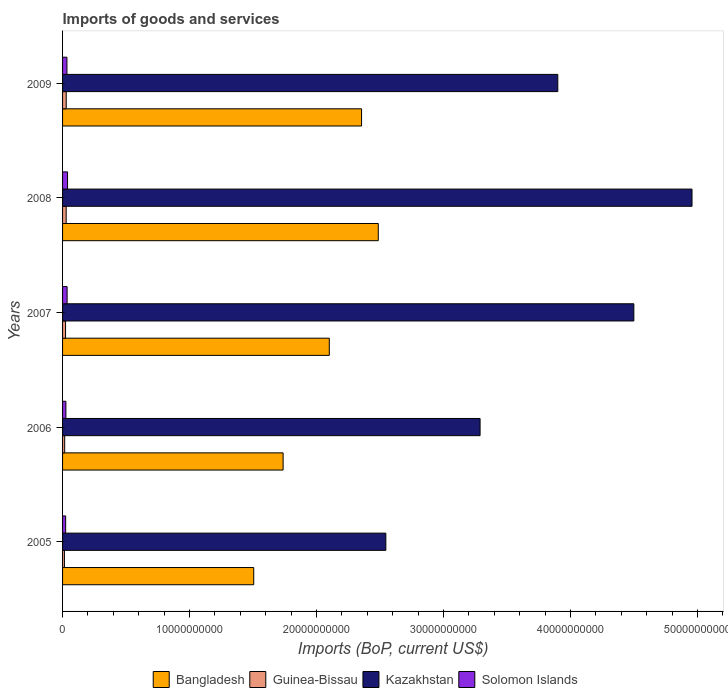How many different coloured bars are there?
Ensure brevity in your answer.  4. Are the number of bars per tick equal to the number of legend labels?
Your answer should be very brief. Yes. How many bars are there on the 3rd tick from the bottom?
Provide a succinct answer. 4. What is the label of the 4th group of bars from the top?
Ensure brevity in your answer.  2006. In how many cases, is the number of bars for a given year not equal to the number of legend labels?
Keep it short and to the point. 0. What is the amount spent on imports in Bangladesh in 2008?
Your response must be concise. 2.49e+1. Across all years, what is the maximum amount spent on imports in Guinea-Bissau?
Provide a short and direct response. 2.89e+08. Across all years, what is the minimum amount spent on imports in Solomon Islands?
Your answer should be compact. 2.43e+08. In which year was the amount spent on imports in Solomon Islands maximum?
Your answer should be compact. 2008. In which year was the amount spent on imports in Bangladesh minimum?
Offer a terse response. 2005. What is the total amount spent on imports in Solomon Islands in the graph?
Give a very brief answer. 1.60e+09. What is the difference between the amount spent on imports in Bangladesh in 2005 and that in 2006?
Provide a succinct answer. -2.31e+09. What is the difference between the amount spent on imports in Bangladesh in 2008 and the amount spent on imports in Guinea-Bissau in 2007?
Provide a short and direct response. 2.46e+1. What is the average amount spent on imports in Kazakhstan per year?
Keep it short and to the point. 3.84e+1. In the year 2007, what is the difference between the amount spent on imports in Solomon Islands and amount spent on imports in Bangladesh?
Keep it short and to the point. -2.06e+1. What is the ratio of the amount spent on imports in Kazakhstan in 2005 to that in 2008?
Give a very brief answer. 0.51. Is the amount spent on imports in Guinea-Bissau in 2006 less than that in 2007?
Keep it short and to the point. Yes. Is the difference between the amount spent on imports in Solomon Islands in 2006 and 2009 greater than the difference between the amount spent on imports in Bangladesh in 2006 and 2009?
Offer a terse response. Yes. What is the difference between the highest and the second highest amount spent on imports in Solomon Islands?
Your answer should be very brief. 3.50e+07. What is the difference between the highest and the lowest amount spent on imports in Bangladesh?
Your response must be concise. 9.81e+09. In how many years, is the amount spent on imports in Solomon Islands greater than the average amount spent on imports in Solomon Islands taken over all years?
Keep it short and to the point. 3. Is the sum of the amount spent on imports in Guinea-Bissau in 2006 and 2009 greater than the maximum amount spent on imports in Kazakhstan across all years?
Your response must be concise. No. What does the 4th bar from the top in 2009 represents?
Keep it short and to the point. Bangladesh. What does the 2nd bar from the bottom in 2007 represents?
Offer a very short reply. Guinea-Bissau. Are all the bars in the graph horizontal?
Offer a terse response. Yes. What is the difference between two consecutive major ticks on the X-axis?
Provide a succinct answer. 1.00e+1. Does the graph contain any zero values?
Provide a succinct answer. No. How are the legend labels stacked?
Ensure brevity in your answer.  Horizontal. What is the title of the graph?
Ensure brevity in your answer.  Imports of goods and services. Does "East Asia (developing only)" appear as one of the legend labels in the graph?
Your response must be concise. No. What is the label or title of the X-axis?
Your response must be concise. Imports (BoP, current US$). What is the Imports (BoP, current US$) in Bangladesh in 2005?
Ensure brevity in your answer.  1.51e+1. What is the Imports (BoP, current US$) in Guinea-Bissau in 2005?
Offer a very short reply. 1.48e+08. What is the Imports (BoP, current US$) in Kazakhstan in 2005?
Ensure brevity in your answer.  2.55e+1. What is the Imports (BoP, current US$) in Solomon Islands in 2005?
Your answer should be very brief. 2.43e+08. What is the Imports (BoP, current US$) of Bangladesh in 2006?
Your answer should be compact. 1.74e+1. What is the Imports (BoP, current US$) of Guinea-Bissau in 2006?
Give a very brief answer. 1.67e+08. What is the Imports (BoP, current US$) of Kazakhstan in 2006?
Give a very brief answer. 3.29e+1. What is the Imports (BoP, current US$) of Solomon Islands in 2006?
Offer a very short reply. 2.63e+08. What is the Imports (BoP, current US$) of Bangladesh in 2007?
Your answer should be compact. 2.10e+1. What is the Imports (BoP, current US$) in Guinea-Bissau in 2007?
Offer a very short reply. 2.36e+08. What is the Imports (BoP, current US$) of Kazakhstan in 2007?
Provide a succinct answer. 4.50e+1. What is the Imports (BoP, current US$) in Solomon Islands in 2007?
Keep it short and to the point. 3.58e+08. What is the Imports (BoP, current US$) of Bangladesh in 2008?
Offer a terse response. 2.49e+1. What is the Imports (BoP, current US$) in Guinea-Bissau in 2008?
Keep it short and to the point. 2.84e+08. What is the Imports (BoP, current US$) of Kazakhstan in 2008?
Provide a succinct answer. 4.96e+1. What is the Imports (BoP, current US$) of Solomon Islands in 2008?
Your answer should be very brief. 3.93e+08. What is the Imports (BoP, current US$) of Bangladesh in 2009?
Offer a very short reply. 2.35e+1. What is the Imports (BoP, current US$) in Guinea-Bissau in 2009?
Keep it short and to the point. 2.89e+08. What is the Imports (BoP, current US$) of Kazakhstan in 2009?
Your answer should be compact. 3.90e+1. What is the Imports (BoP, current US$) of Solomon Islands in 2009?
Ensure brevity in your answer.  3.44e+08. Across all years, what is the maximum Imports (BoP, current US$) in Bangladesh?
Offer a terse response. 2.49e+1. Across all years, what is the maximum Imports (BoP, current US$) in Guinea-Bissau?
Your answer should be compact. 2.89e+08. Across all years, what is the maximum Imports (BoP, current US$) in Kazakhstan?
Make the answer very short. 4.96e+1. Across all years, what is the maximum Imports (BoP, current US$) in Solomon Islands?
Make the answer very short. 3.93e+08. Across all years, what is the minimum Imports (BoP, current US$) in Bangladesh?
Your answer should be very brief. 1.51e+1. Across all years, what is the minimum Imports (BoP, current US$) of Guinea-Bissau?
Ensure brevity in your answer.  1.48e+08. Across all years, what is the minimum Imports (BoP, current US$) of Kazakhstan?
Provide a short and direct response. 2.55e+1. Across all years, what is the minimum Imports (BoP, current US$) of Solomon Islands?
Offer a very short reply. 2.43e+08. What is the total Imports (BoP, current US$) of Bangladesh in the graph?
Your answer should be compact. 1.02e+11. What is the total Imports (BoP, current US$) of Guinea-Bissau in the graph?
Ensure brevity in your answer.  1.12e+09. What is the total Imports (BoP, current US$) in Kazakhstan in the graph?
Keep it short and to the point. 1.92e+11. What is the total Imports (BoP, current US$) in Solomon Islands in the graph?
Provide a short and direct response. 1.60e+09. What is the difference between the Imports (BoP, current US$) of Bangladesh in 2005 and that in 2006?
Offer a terse response. -2.31e+09. What is the difference between the Imports (BoP, current US$) of Guinea-Bissau in 2005 and that in 2006?
Offer a very short reply. -1.90e+07. What is the difference between the Imports (BoP, current US$) in Kazakhstan in 2005 and that in 2006?
Your answer should be compact. -7.42e+09. What is the difference between the Imports (BoP, current US$) in Solomon Islands in 2005 and that in 2006?
Give a very brief answer. -2.03e+07. What is the difference between the Imports (BoP, current US$) of Bangladesh in 2005 and that in 2007?
Offer a terse response. -5.95e+09. What is the difference between the Imports (BoP, current US$) of Guinea-Bissau in 2005 and that in 2007?
Your answer should be compact. -8.85e+07. What is the difference between the Imports (BoP, current US$) of Kazakhstan in 2005 and that in 2007?
Offer a terse response. -1.95e+1. What is the difference between the Imports (BoP, current US$) in Solomon Islands in 2005 and that in 2007?
Your answer should be very brief. -1.15e+08. What is the difference between the Imports (BoP, current US$) in Bangladesh in 2005 and that in 2008?
Make the answer very short. -9.81e+09. What is the difference between the Imports (BoP, current US$) of Guinea-Bissau in 2005 and that in 2008?
Your answer should be very brief. -1.36e+08. What is the difference between the Imports (BoP, current US$) of Kazakhstan in 2005 and that in 2008?
Provide a short and direct response. -2.41e+1. What is the difference between the Imports (BoP, current US$) of Solomon Islands in 2005 and that in 2008?
Offer a terse response. -1.50e+08. What is the difference between the Imports (BoP, current US$) of Bangladesh in 2005 and that in 2009?
Ensure brevity in your answer.  -8.49e+09. What is the difference between the Imports (BoP, current US$) in Guinea-Bissau in 2005 and that in 2009?
Your answer should be very brief. -1.42e+08. What is the difference between the Imports (BoP, current US$) of Kazakhstan in 2005 and that in 2009?
Make the answer very short. -1.35e+1. What is the difference between the Imports (BoP, current US$) in Solomon Islands in 2005 and that in 2009?
Provide a short and direct response. -1.01e+08. What is the difference between the Imports (BoP, current US$) in Bangladesh in 2006 and that in 2007?
Keep it short and to the point. -3.64e+09. What is the difference between the Imports (BoP, current US$) of Guinea-Bissau in 2006 and that in 2007?
Give a very brief answer. -6.95e+07. What is the difference between the Imports (BoP, current US$) of Kazakhstan in 2006 and that in 2007?
Keep it short and to the point. -1.21e+1. What is the difference between the Imports (BoP, current US$) of Solomon Islands in 2006 and that in 2007?
Provide a succinct answer. -9.44e+07. What is the difference between the Imports (BoP, current US$) of Bangladesh in 2006 and that in 2008?
Make the answer very short. -7.50e+09. What is the difference between the Imports (BoP, current US$) of Guinea-Bissau in 2006 and that in 2008?
Provide a short and direct response. -1.17e+08. What is the difference between the Imports (BoP, current US$) in Kazakhstan in 2006 and that in 2008?
Ensure brevity in your answer.  -1.67e+1. What is the difference between the Imports (BoP, current US$) of Solomon Islands in 2006 and that in 2008?
Ensure brevity in your answer.  -1.29e+08. What is the difference between the Imports (BoP, current US$) in Bangladesh in 2006 and that in 2009?
Provide a succinct answer. -6.18e+09. What is the difference between the Imports (BoP, current US$) in Guinea-Bissau in 2006 and that in 2009?
Make the answer very short. -1.23e+08. What is the difference between the Imports (BoP, current US$) of Kazakhstan in 2006 and that in 2009?
Your response must be concise. -6.12e+09. What is the difference between the Imports (BoP, current US$) in Solomon Islands in 2006 and that in 2009?
Your answer should be very brief. -8.06e+07. What is the difference between the Imports (BoP, current US$) of Bangladesh in 2007 and that in 2008?
Your answer should be very brief. -3.86e+09. What is the difference between the Imports (BoP, current US$) in Guinea-Bissau in 2007 and that in 2008?
Your response must be concise. -4.78e+07. What is the difference between the Imports (BoP, current US$) of Kazakhstan in 2007 and that in 2008?
Your response must be concise. -4.58e+09. What is the difference between the Imports (BoP, current US$) in Solomon Islands in 2007 and that in 2008?
Keep it short and to the point. -3.50e+07. What is the difference between the Imports (BoP, current US$) of Bangladesh in 2007 and that in 2009?
Your answer should be very brief. -2.54e+09. What is the difference between the Imports (BoP, current US$) in Guinea-Bissau in 2007 and that in 2009?
Your answer should be compact. -5.31e+07. What is the difference between the Imports (BoP, current US$) in Kazakhstan in 2007 and that in 2009?
Provide a succinct answer. 5.99e+09. What is the difference between the Imports (BoP, current US$) in Solomon Islands in 2007 and that in 2009?
Provide a succinct answer. 1.37e+07. What is the difference between the Imports (BoP, current US$) in Bangladesh in 2008 and that in 2009?
Provide a short and direct response. 1.32e+09. What is the difference between the Imports (BoP, current US$) in Guinea-Bissau in 2008 and that in 2009?
Give a very brief answer. -5.23e+06. What is the difference between the Imports (BoP, current US$) of Kazakhstan in 2008 and that in 2009?
Your answer should be compact. 1.06e+1. What is the difference between the Imports (BoP, current US$) of Solomon Islands in 2008 and that in 2009?
Your answer should be very brief. 4.87e+07. What is the difference between the Imports (BoP, current US$) of Bangladesh in 2005 and the Imports (BoP, current US$) of Guinea-Bissau in 2006?
Offer a terse response. 1.49e+1. What is the difference between the Imports (BoP, current US$) in Bangladesh in 2005 and the Imports (BoP, current US$) in Kazakhstan in 2006?
Your response must be concise. -1.78e+1. What is the difference between the Imports (BoP, current US$) in Bangladesh in 2005 and the Imports (BoP, current US$) in Solomon Islands in 2006?
Your response must be concise. 1.48e+1. What is the difference between the Imports (BoP, current US$) of Guinea-Bissau in 2005 and the Imports (BoP, current US$) of Kazakhstan in 2006?
Offer a terse response. -3.27e+1. What is the difference between the Imports (BoP, current US$) of Guinea-Bissau in 2005 and the Imports (BoP, current US$) of Solomon Islands in 2006?
Give a very brief answer. -1.16e+08. What is the difference between the Imports (BoP, current US$) in Kazakhstan in 2005 and the Imports (BoP, current US$) in Solomon Islands in 2006?
Make the answer very short. 2.52e+1. What is the difference between the Imports (BoP, current US$) in Bangladesh in 2005 and the Imports (BoP, current US$) in Guinea-Bissau in 2007?
Keep it short and to the point. 1.48e+1. What is the difference between the Imports (BoP, current US$) in Bangladesh in 2005 and the Imports (BoP, current US$) in Kazakhstan in 2007?
Provide a short and direct response. -2.99e+1. What is the difference between the Imports (BoP, current US$) of Bangladesh in 2005 and the Imports (BoP, current US$) of Solomon Islands in 2007?
Give a very brief answer. 1.47e+1. What is the difference between the Imports (BoP, current US$) of Guinea-Bissau in 2005 and the Imports (BoP, current US$) of Kazakhstan in 2007?
Give a very brief answer. -4.48e+1. What is the difference between the Imports (BoP, current US$) in Guinea-Bissau in 2005 and the Imports (BoP, current US$) in Solomon Islands in 2007?
Provide a short and direct response. -2.10e+08. What is the difference between the Imports (BoP, current US$) in Kazakhstan in 2005 and the Imports (BoP, current US$) in Solomon Islands in 2007?
Your response must be concise. 2.51e+1. What is the difference between the Imports (BoP, current US$) of Bangladesh in 2005 and the Imports (BoP, current US$) of Guinea-Bissau in 2008?
Provide a succinct answer. 1.48e+1. What is the difference between the Imports (BoP, current US$) of Bangladesh in 2005 and the Imports (BoP, current US$) of Kazakhstan in 2008?
Provide a succinct answer. -3.45e+1. What is the difference between the Imports (BoP, current US$) of Bangladesh in 2005 and the Imports (BoP, current US$) of Solomon Islands in 2008?
Keep it short and to the point. 1.47e+1. What is the difference between the Imports (BoP, current US$) of Guinea-Bissau in 2005 and the Imports (BoP, current US$) of Kazakhstan in 2008?
Your answer should be compact. -4.94e+1. What is the difference between the Imports (BoP, current US$) of Guinea-Bissau in 2005 and the Imports (BoP, current US$) of Solomon Islands in 2008?
Your response must be concise. -2.45e+08. What is the difference between the Imports (BoP, current US$) in Kazakhstan in 2005 and the Imports (BoP, current US$) in Solomon Islands in 2008?
Give a very brief answer. 2.51e+1. What is the difference between the Imports (BoP, current US$) of Bangladesh in 2005 and the Imports (BoP, current US$) of Guinea-Bissau in 2009?
Make the answer very short. 1.48e+1. What is the difference between the Imports (BoP, current US$) of Bangladesh in 2005 and the Imports (BoP, current US$) of Kazakhstan in 2009?
Keep it short and to the point. -2.39e+1. What is the difference between the Imports (BoP, current US$) of Bangladesh in 2005 and the Imports (BoP, current US$) of Solomon Islands in 2009?
Provide a succinct answer. 1.47e+1. What is the difference between the Imports (BoP, current US$) in Guinea-Bissau in 2005 and the Imports (BoP, current US$) in Kazakhstan in 2009?
Make the answer very short. -3.89e+1. What is the difference between the Imports (BoP, current US$) in Guinea-Bissau in 2005 and the Imports (BoP, current US$) in Solomon Islands in 2009?
Your answer should be very brief. -1.96e+08. What is the difference between the Imports (BoP, current US$) of Kazakhstan in 2005 and the Imports (BoP, current US$) of Solomon Islands in 2009?
Provide a succinct answer. 2.51e+1. What is the difference between the Imports (BoP, current US$) of Bangladesh in 2006 and the Imports (BoP, current US$) of Guinea-Bissau in 2007?
Provide a succinct answer. 1.71e+1. What is the difference between the Imports (BoP, current US$) of Bangladesh in 2006 and the Imports (BoP, current US$) of Kazakhstan in 2007?
Provide a short and direct response. -2.76e+1. What is the difference between the Imports (BoP, current US$) in Bangladesh in 2006 and the Imports (BoP, current US$) in Solomon Islands in 2007?
Ensure brevity in your answer.  1.70e+1. What is the difference between the Imports (BoP, current US$) in Guinea-Bissau in 2006 and the Imports (BoP, current US$) in Kazakhstan in 2007?
Keep it short and to the point. -4.48e+1. What is the difference between the Imports (BoP, current US$) of Guinea-Bissau in 2006 and the Imports (BoP, current US$) of Solomon Islands in 2007?
Ensure brevity in your answer.  -1.91e+08. What is the difference between the Imports (BoP, current US$) of Kazakhstan in 2006 and the Imports (BoP, current US$) of Solomon Islands in 2007?
Make the answer very short. 3.25e+1. What is the difference between the Imports (BoP, current US$) of Bangladesh in 2006 and the Imports (BoP, current US$) of Guinea-Bissau in 2008?
Keep it short and to the point. 1.71e+1. What is the difference between the Imports (BoP, current US$) of Bangladesh in 2006 and the Imports (BoP, current US$) of Kazakhstan in 2008?
Give a very brief answer. -3.22e+1. What is the difference between the Imports (BoP, current US$) in Bangladesh in 2006 and the Imports (BoP, current US$) in Solomon Islands in 2008?
Your response must be concise. 1.70e+1. What is the difference between the Imports (BoP, current US$) in Guinea-Bissau in 2006 and the Imports (BoP, current US$) in Kazakhstan in 2008?
Keep it short and to the point. -4.94e+1. What is the difference between the Imports (BoP, current US$) of Guinea-Bissau in 2006 and the Imports (BoP, current US$) of Solomon Islands in 2008?
Provide a succinct answer. -2.26e+08. What is the difference between the Imports (BoP, current US$) of Kazakhstan in 2006 and the Imports (BoP, current US$) of Solomon Islands in 2008?
Your answer should be very brief. 3.25e+1. What is the difference between the Imports (BoP, current US$) of Bangladesh in 2006 and the Imports (BoP, current US$) of Guinea-Bissau in 2009?
Give a very brief answer. 1.71e+1. What is the difference between the Imports (BoP, current US$) in Bangladesh in 2006 and the Imports (BoP, current US$) in Kazakhstan in 2009?
Your answer should be compact. -2.16e+1. What is the difference between the Imports (BoP, current US$) of Bangladesh in 2006 and the Imports (BoP, current US$) of Solomon Islands in 2009?
Offer a terse response. 1.70e+1. What is the difference between the Imports (BoP, current US$) of Guinea-Bissau in 2006 and the Imports (BoP, current US$) of Kazakhstan in 2009?
Give a very brief answer. -3.88e+1. What is the difference between the Imports (BoP, current US$) in Guinea-Bissau in 2006 and the Imports (BoP, current US$) in Solomon Islands in 2009?
Provide a short and direct response. -1.77e+08. What is the difference between the Imports (BoP, current US$) of Kazakhstan in 2006 and the Imports (BoP, current US$) of Solomon Islands in 2009?
Offer a very short reply. 3.25e+1. What is the difference between the Imports (BoP, current US$) of Bangladesh in 2007 and the Imports (BoP, current US$) of Guinea-Bissau in 2008?
Provide a short and direct response. 2.07e+1. What is the difference between the Imports (BoP, current US$) in Bangladesh in 2007 and the Imports (BoP, current US$) in Kazakhstan in 2008?
Ensure brevity in your answer.  -2.86e+1. What is the difference between the Imports (BoP, current US$) of Bangladesh in 2007 and the Imports (BoP, current US$) of Solomon Islands in 2008?
Make the answer very short. 2.06e+1. What is the difference between the Imports (BoP, current US$) in Guinea-Bissau in 2007 and the Imports (BoP, current US$) in Kazakhstan in 2008?
Your answer should be compact. -4.93e+1. What is the difference between the Imports (BoP, current US$) in Guinea-Bissau in 2007 and the Imports (BoP, current US$) in Solomon Islands in 2008?
Give a very brief answer. -1.57e+08. What is the difference between the Imports (BoP, current US$) of Kazakhstan in 2007 and the Imports (BoP, current US$) of Solomon Islands in 2008?
Keep it short and to the point. 4.46e+1. What is the difference between the Imports (BoP, current US$) of Bangladesh in 2007 and the Imports (BoP, current US$) of Guinea-Bissau in 2009?
Provide a short and direct response. 2.07e+1. What is the difference between the Imports (BoP, current US$) of Bangladesh in 2007 and the Imports (BoP, current US$) of Kazakhstan in 2009?
Your answer should be compact. -1.80e+1. What is the difference between the Imports (BoP, current US$) in Bangladesh in 2007 and the Imports (BoP, current US$) in Solomon Islands in 2009?
Provide a short and direct response. 2.07e+1. What is the difference between the Imports (BoP, current US$) of Guinea-Bissau in 2007 and the Imports (BoP, current US$) of Kazakhstan in 2009?
Provide a succinct answer. -3.88e+1. What is the difference between the Imports (BoP, current US$) in Guinea-Bissau in 2007 and the Imports (BoP, current US$) in Solomon Islands in 2009?
Your answer should be compact. -1.08e+08. What is the difference between the Imports (BoP, current US$) of Kazakhstan in 2007 and the Imports (BoP, current US$) of Solomon Islands in 2009?
Your answer should be compact. 4.46e+1. What is the difference between the Imports (BoP, current US$) of Bangladesh in 2008 and the Imports (BoP, current US$) of Guinea-Bissau in 2009?
Your answer should be compact. 2.46e+1. What is the difference between the Imports (BoP, current US$) of Bangladesh in 2008 and the Imports (BoP, current US$) of Kazakhstan in 2009?
Offer a terse response. -1.41e+1. What is the difference between the Imports (BoP, current US$) in Bangladesh in 2008 and the Imports (BoP, current US$) in Solomon Islands in 2009?
Your response must be concise. 2.45e+1. What is the difference between the Imports (BoP, current US$) of Guinea-Bissau in 2008 and the Imports (BoP, current US$) of Kazakhstan in 2009?
Your answer should be compact. -3.87e+1. What is the difference between the Imports (BoP, current US$) in Guinea-Bissau in 2008 and the Imports (BoP, current US$) in Solomon Islands in 2009?
Your answer should be very brief. -6.01e+07. What is the difference between the Imports (BoP, current US$) in Kazakhstan in 2008 and the Imports (BoP, current US$) in Solomon Islands in 2009?
Keep it short and to the point. 4.92e+1. What is the average Imports (BoP, current US$) in Bangladesh per year?
Your response must be concise. 2.04e+1. What is the average Imports (BoP, current US$) of Guinea-Bissau per year?
Your answer should be compact. 2.25e+08. What is the average Imports (BoP, current US$) in Kazakhstan per year?
Provide a short and direct response. 3.84e+1. What is the average Imports (BoP, current US$) in Solomon Islands per year?
Provide a short and direct response. 3.20e+08. In the year 2005, what is the difference between the Imports (BoP, current US$) of Bangladesh and Imports (BoP, current US$) of Guinea-Bissau?
Provide a short and direct response. 1.49e+1. In the year 2005, what is the difference between the Imports (BoP, current US$) in Bangladesh and Imports (BoP, current US$) in Kazakhstan?
Provide a succinct answer. -1.04e+1. In the year 2005, what is the difference between the Imports (BoP, current US$) of Bangladesh and Imports (BoP, current US$) of Solomon Islands?
Your response must be concise. 1.48e+1. In the year 2005, what is the difference between the Imports (BoP, current US$) of Guinea-Bissau and Imports (BoP, current US$) of Kazakhstan?
Keep it short and to the point. -2.53e+1. In the year 2005, what is the difference between the Imports (BoP, current US$) of Guinea-Bissau and Imports (BoP, current US$) of Solomon Islands?
Provide a succinct answer. -9.54e+07. In the year 2005, what is the difference between the Imports (BoP, current US$) in Kazakhstan and Imports (BoP, current US$) in Solomon Islands?
Your answer should be compact. 2.52e+1. In the year 2006, what is the difference between the Imports (BoP, current US$) in Bangladesh and Imports (BoP, current US$) in Guinea-Bissau?
Provide a succinct answer. 1.72e+1. In the year 2006, what is the difference between the Imports (BoP, current US$) of Bangladesh and Imports (BoP, current US$) of Kazakhstan?
Offer a terse response. -1.55e+1. In the year 2006, what is the difference between the Imports (BoP, current US$) of Bangladesh and Imports (BoP, current US$) of Solomon Islands?
Ensure brevity in your answer.  1.71e+1. In the year 2006, what is the difference between the Imports (BoP, current US$) of Guinea-Bissau and Imports (BoP, current US$) of Kazakhstan?
Offer a very short reply. -3.27e+1. In the year 2006, what is the difference between the Imports (BoP, current US$) of Guinea-Bissau and Imports (BoP, current US$) of Solomon Islands?
Ensure brevity in your answer.  -9.68e+07. In the year 2006, what is the difference between the Imports (BoP, current US$) in Kazakhstan and Imports (BoP, current US$) in Solomon Islands?
Provide a succinct answer. 3.26e+1. In the year 2007, what is the difference between the Imports (BoP, current US$) in Bangladesh and Imports (BoP, current US$) in Guinea-Bissau?
Keep it short and to the point. 2.08e+1. In the year 2007, what is the difference between the Imports (BoP, current US$) of Bangladesh and Imports (BoP, current US$) of Kazakhstan?
Give a very brief answer. -2.40e+1. In the year 2007, what is the difference between the Imports (BoP, current US$) in Bangladesh and Imports (BoP, current US$) in Solomon Islands?
Keep it short and to the point. 2.06e+1. In the year 2007, what is the difference between the Imports (BoP, current US$) of Guinea-Bissau and Imports (BoP, current US$) of Kazakhstan?
Provide a succinct answer. -4.48e+1. In the year 2007, what is the difference between the Imports (BoP, current US$) of Guinea-Bissau and Imports (BoP, current US$) of Solomon Islands?
Provide a succinct answer. -1.22e+08. In the year 2007, what is the difference between the Imports (BoP, current US$) of Kazakhstan and Imports (BoP, current US$) of Solomon Islands?
Offer a very short reply. 4.46e+1. In the year 2008, what is the difference between the Imports (BoP, current US$) in Bangladesh and Imports (BoP, current US$) in Guinea-Bissau?
Make the answer very short. 2.46e+1. In the year 2008, what is the difference between the Imports (BoP, current US$) in Bangladesh and Imports (BoP, current US$) in Kazakhstan?
Provide a succinct answer. -2.47e+1. In the year 2008, what is the difference between the Imports (BoP, current US$) in Bangladesh and Imports (BoP, current US$) in Solomon Islands?
Your answer should be compact. 2.45e+1. In the year 2008, what is the difference between the Imports (BoP, current US$) of Guinea-Bissau and Imports (BoP, current US$) of Kazakhstan?
Ensure brevity in your answer.  -4.93e+1. In the year 2008, what is the difference between the Imports (BoP, current US$) of Guinea-Bissau and Imports (BoP, current US$) of Solomon Islands?
Make the answer very short. -1.09e+08. In the year 2008, what is the difference between the Imports (BoP, current US$) in Kazakhstan and Imports (BoP, current US$) in Solomon Islands?
Provide a succinct answer. 4.92e+1. In the year 2009, what is the difference between the Imports (BoP, current US$) of Bangladesh and Imports (BoP, current US$) of Guinea-Bissau?
Offer a very short reply. 2.33e+1. In the year 2009, what is the difference between the Imports (BoP, current US$) of Bangladesh and Imports (BoP, current US$) of Kazakhstan?
Ensure brevity in your answer.  -1.55e+1. In the year 2009, what is the difference between the Imports (BoP, current US$) of Bangladesh and Imports (BoP, current US$) of Solomon Islands?
Give a very brief answer. 2.32e+1. In the year 2009, what is the difference between the Imports (BoP, current US$) of Guinea-Bissau and Imports (BoP, current US$) of Kazakhstan?
Offer a very short reply. -3.87e+1. In the year 2009, what is the difference between the Imports (BoP, current US$) in Guinea-Bissau and Imports (BoP, current US$) in Solomon Islands?
Provide a short and direct response. -5.48e+07. In the year 2009, what is the difference between the Imports (BoP, current US$) in Kazakhstan and Imports (BoP, current US$) in Solomon Islands?
Ensure brevity in your answer.  3.87e+1. What is the ratio of the Imports (BoP, current US$) of Bangladesh in 2005 to that in 2006?
Give a very brief answer. 0.87. What is the ratio of the Imports (BoP, current US$) of Guinea-Bissau in 2005 to that in 2006?
Your answer should be very brief. 0.89. What is the ratio of the Imports (BoP, current US$) of Kazakhstan in 2005 to that in 2006?
Offer a very short reply. 0.77. What is the ratio of the Imports (BoP, current US$) in Solomon Islands in 2005 to that in 2006?
Offer a terse response. 0.92. What is the ratio of the Imports (BoP, current US$) in Bangladesh in 2005 to that in 2007?
Offer a terse response. 0.72. What is the ratio of the Imports (BoP, current US$) of Guinea-Bissau in 2005 to that in 2007?
Your response must be concise. 0.63. What is the ratio of the Imports (BoP, current US$) in Kazakhstan in 2005 to that in 2007?
Provide a succinct answer. 0.57. What is the ratio of the Imports (BoP, current US$) in Solomon Islands in 2005 to that in 2007?
Make the answer very short. 0.68. What is the ratio of the Imports (BoP, current US$) in Bangladesh in 2005 to that in 2008?
Ensure brevity in your answer.  0.61. What is the ratio of the Imports (BoP, current US$) of Guinea-Bissau in 2005 to that in 2008?
Your answer should be very brief. 0.52. What is the ratio of the Imports (BoP, current US$) in Kazakhstan in 2005 to that in 2008?
Provide a succinct answer. 0.51. What is the ratio of the Imports (BoP, current US$) in Solomon Islands in 2005 to that in 2008?
Your answer should be compact. 0.62. What is the ratio of the Imports (BoP, current US$) of Bangladesh in 2005 to that in 2009?
Your answer should be very brief. 0.64. What is the ratio of the Imports (BoP, current US$) in Guinea-Bissau in 2005 to that in 2009?
Give a very brief answer. 0.51. What is the ratio of the Imports (BoP, current US$) in Kazakhstan in 2005 to that in 2009?
Ensure brevity in your answer.  0.65. What is the ratio of the Imports (BoP, current US$) of Solomon Islands in 2005 to that in 2009?
Keep it short and to the point. 0.71. What is the ratio of the Imports (BoP, current US$) of Bangladesh in 2006 to that in 2007?
Your response must be concise. 0.83. What is the ratio of the Imports (BoP, current US$) in Guinea-Bissau in 2006 to that in 2007?
Provide a succinct answer. 0.71. What is the ratio of the Imports (BoP, current US$) of Kazakhstan in 2006 to that in 2007?
Offer a very short reply. 0.73. What is the ratio of the Imports (BoP, current US$) in Solomon Islands in 2006 to that in 2007?
Your answer should be compact. 0.74. What is the ratio of the Imports (BoP, current US$) in Bangladesh in 2006 to that in 2008?
Make the answer very short. 0.7. What is the ratio of the Imports (BoP, current US$) of Guinea-Bissau in 2006 to that in 2008?
Your answer should be very brief. 0.59. What is the ratio of the Imports (BoP, current US$) of Kazakhstan in 2006 to that in 2008?
Offer a terse response. 0.66. What is the ratio of the Imports (BoP, current US$) in Solomon Islands in 2006 to that in 2008?
Ensure brevity in your answer.  0.67. What is the ratio of the Imports (BoP, current US$) in Bangladesh in 2006 to that in 2009?
Ensure brevity in your answer.  0.74. What is the ratio of the Imports (BoP, current US$) in Guinea-Bissau in 2006 to that in 2009?
Your response must be concise. 0.58. What is the ratio of the Imports (BoP, current US$) of Kazakhstan in 2006 to that in 2009?
Provide a short and direct response. 0.84. What is the ratio of the Imports (BoP, current US$) of Solomon Islands in 2006 to that in 2009?
Offer a very short reply. 0.77. What is the ratio of the Imports (BoP, current US$) of Bangladesh in 2007 to that in 2008?
Keep it short and to the point. 0.84. What is the ratio of the Imports (BoP, current US$) in Guinea-Bissau in 2007 to that in 2008?
Give a very brief answer. 0.83. What is the ratio of the Imports (BoP, current US$) in Kazakhstan in 2007 to that in 2008?
Your response must be concise. 0.91. What is the ratio of the Imports (BoP, current US$) of Solomon Islands in 2007 to that in 2008?
Your answer should be compact. 0.91. What is the ratio of the Imports (BoP, current US$) of Bangladesh in 2007 to that in 2009?
Your answer should be compact. 0.89. What is the ratio of the Imports (BoP, current US$) of Guinea-Bissau in 2007 to that in 2009?
Offer a very short reply. 0.82. What is the ratio of the Imports (BoP, current US$) of Kazakhstan in 2007 to that in 2009?
Give a very brief answer. 1.15. What is the ratio of the Imports (BoP, current US$) in Bangladesh in 2008 to that in 2009?
Your response must be concise. 1.06. What is the ratio of the Imports (BoP, current US$) of Guinea-Bissau in 2008 to that in 2009?
Provide a succinct answer. 0.98. What is the ratio of the Imports (BoP, current US$) of Kazakhstan in 2008 to that in 2009?
Your answer should be very brief. 1.27. What is the ratio of the Imports (BoP, current US$) in Solomon Islands in 2008 to that in 2009?
Your answer should be compact. 1.14. What is the difference between the highest and the second highest Imports (BoP, current US$) of Bangladesh?
Ensure brevity in your answer.  1.32e+09. What is the difference between the highest and the second highest Imports (BoP, current US$) of Guinea-Bissau?
Offer a very short reply. 5.23e+06. What is the difference between the highest and the second highest Imports (BoP, current US$) of Kazakhstan?
Your response must be concise. 4.58e+09. What is the difference between the highest and the second highest Imports (BoP, current US$) in Solomon Islands?
Your answer should be very brief. 3.50e+07. What is the difference between the highest and the lowest Imports (BoP, current US$) of Bangladesh?
Provide a short and direct response. 9.81e+09. What is the difference between the highest and the lowest Imports (BoP, current US$) of Guinea-Bissau?
Make the answer very short. 1.42e+08. What is the difference between the highest and the lowest Imports (BoP, current US$) in Kazakhstan?
Offer a terse response. 2.41e+1. What is the difference between the highest and the lowest Imports (BoP, current US$) of Solomon Islands?
Offer a very short reply. 1.50e+08. 